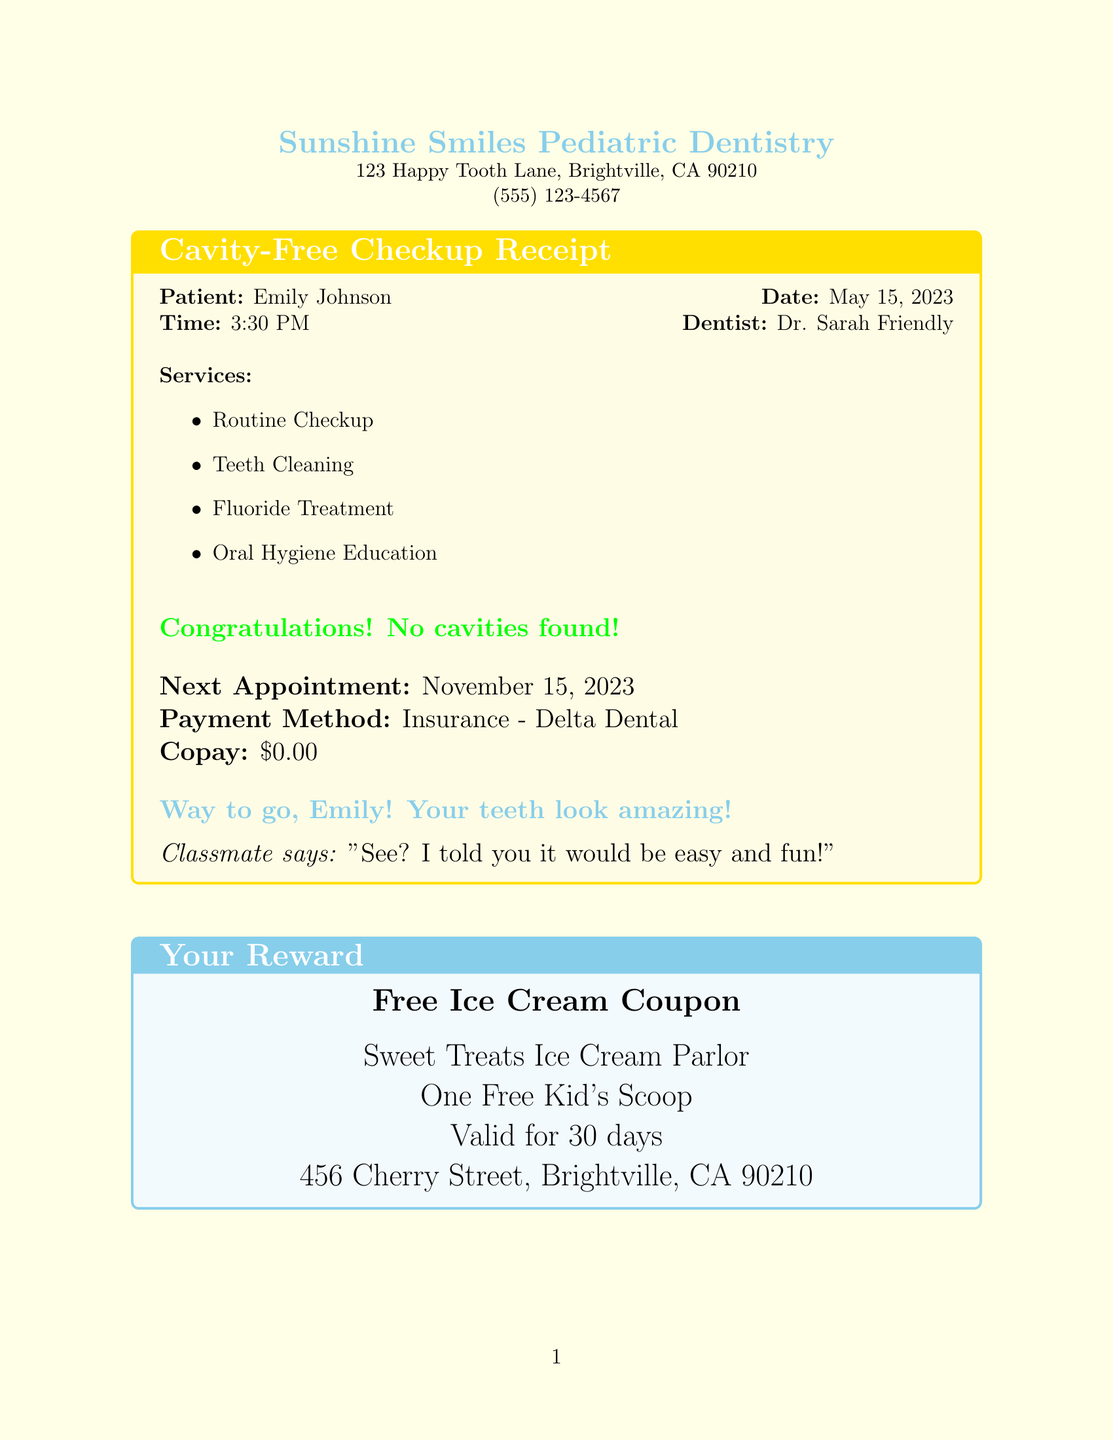What is the name of the dental practice? The name of the dental practice listed in the document is "Sunshine Smiles Pediatric Dentistry."
Answer: Sunshine Smiles Pediatric Dentistry What is the date of Emily's checkup? The document states that Emily's checkup took place on May 15, 2023.
Answer: May 15, 2023 Who is the dentist for this checkup? According to the document, the dentist is named Dr. Sarah Friendly.
Answer: Dr. Sarah Friendly What reward did Emily receive? The document provides a coupon for a free ice cream, which is noted as "One Free Kid's Scoop."
Answer: One Free Kid's Scoop What sticker did Emily earn? The document mentions that Emily earned the "Super Smile Star" sticker.
Answer: Super Smile Star When is Emily's next appointment? The document indicates that Emily's next appointment is on November 15, 2023.
Answer: November 15, 2023 What was the payment method used? The document states that the payment method used was "Insurance - Delta Dental."
Answer: Insurance - Delta Dental What fun fact is noted in the document? The document shares the fun fact about tooth enamel being the hardest substance in the body.
Answer: Tooth enamel is the hardest substance in your body! What oral health tip includes a frequency? The document lists "Floss once a day" as an oral health tip that includes a frequency.
Answer: Floss once a day 